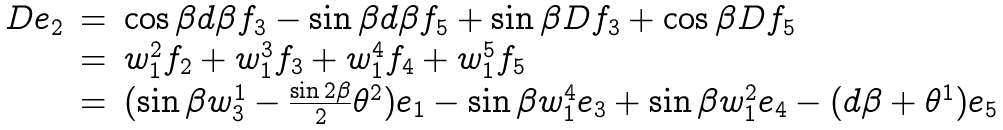<formula> <loc_0><loc_0><loc_500><loc_500>\begin{array} { l c l } D e _ { 2 } & = & \cos \beta d \beta f _ { 3 } - \sin \beta d \beta f _ { 5 } + \sin \beta D f _ { 3 } + \cos \beta D f _ { 5 } \\ & = & w _ { 1 } ^ { 2 } f _ { 2 } + w _ { 1 } ^ { 3 } f _ { 3 } + w _ { 1 } ^ { 4 } f _ { 4 } + w _ { 1 } ^ { 5 } f _ { 5 } \\ & = & ( \sin \beta w _ { 3 } ^ { 1 } - \frac { \sin 2 \beta } { 2 } \theta ^ { 2 } ) e _ { 1 } - \sin \beta w _ { 1 } ^ { 4 } e _ { 3 } + \sin \beta w _ { 1 } ^ { 2 } e _ { 4 } - ( d \beta + \theta ^ { 1 } ) e _ { 5 } \\ \end{array}</formula> 